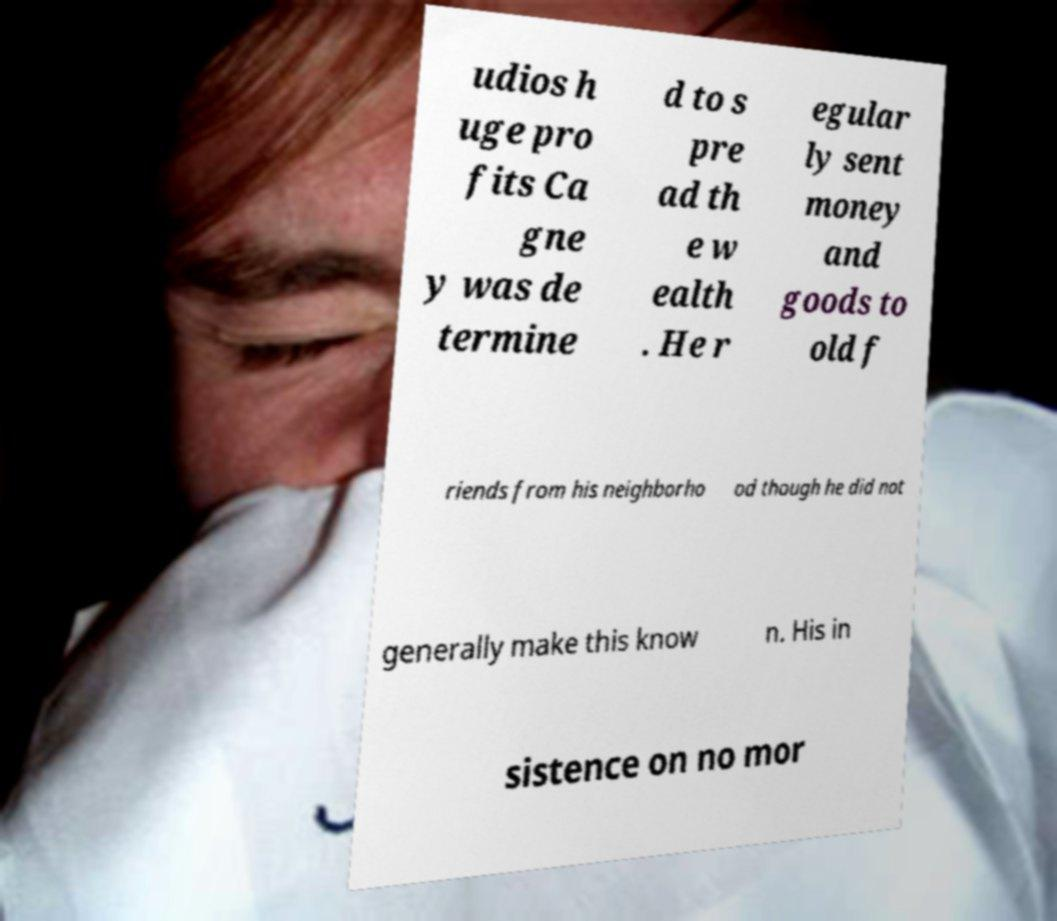There's text embedded in this image that I need extracted. Can you transcribe it verbatim? udios h uge pro fits Ca gne y was de termine d to s pre ad th e w ealth . He r egular ly sent money and goods to old f riends from his neighborho od though he did not generally make this know n. His in sistence on no mor 